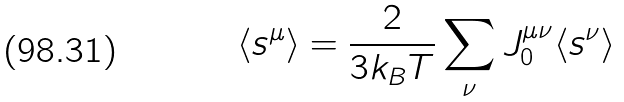<formula> <loc_0><loc_0><loc_500><loc_500>\langle s ^ { \mu } \rangle = \frac { 2 } { 3 k _ { B } T } \sum _ { \nu } J _ { 0 } ^ { \mu \nu } \langle s ^ { \nu } \rangle</formula> 